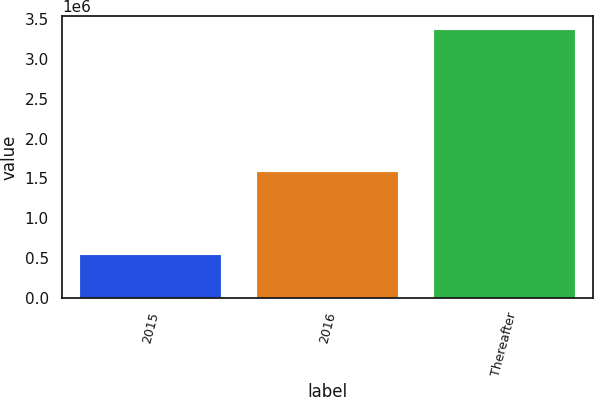Convert chart. <chart><loc_0><loc_0><loc_500><loc_500><bar_chart><fcel>2015<fcel>2016<fcel>Thereafter<nl><fcel>538159<fcel>1.57639e+06<fcel>3.36677e+06<nl></chart> 